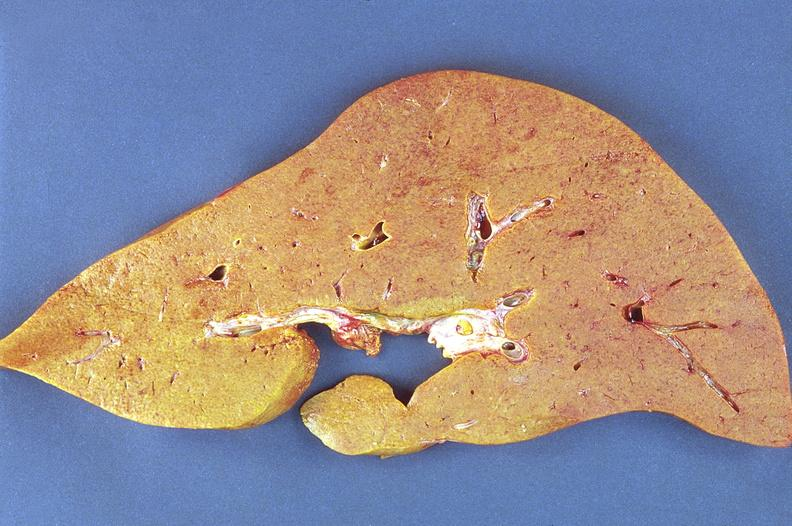s liver present?
Answer the question using a single word or phrase. Yes 